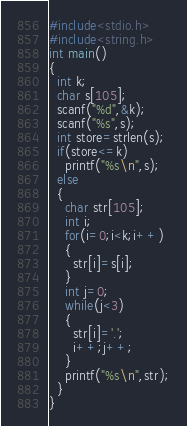<code> <loc_0><loc_0><loc_500><loc_500><_C_>#include<stdio.h>
#include<string.h>
int main()
{
  int k;
  char s[105];
  scanf("%d",&k);
  scanf("%s",s);
  int store=strlen(s);
  if(store<=k)
    printf("%s\n",s);
  else
  {
    char str[105];
    int i;
    for(i=0;i<k;i++)
    {
      str[i]=s[i];
    }
    int j=0;
    while(j<3)
    {
      str[i]='.';
      i++;j++;
    }
    printf("%s\n",str);
  }
}</code> 